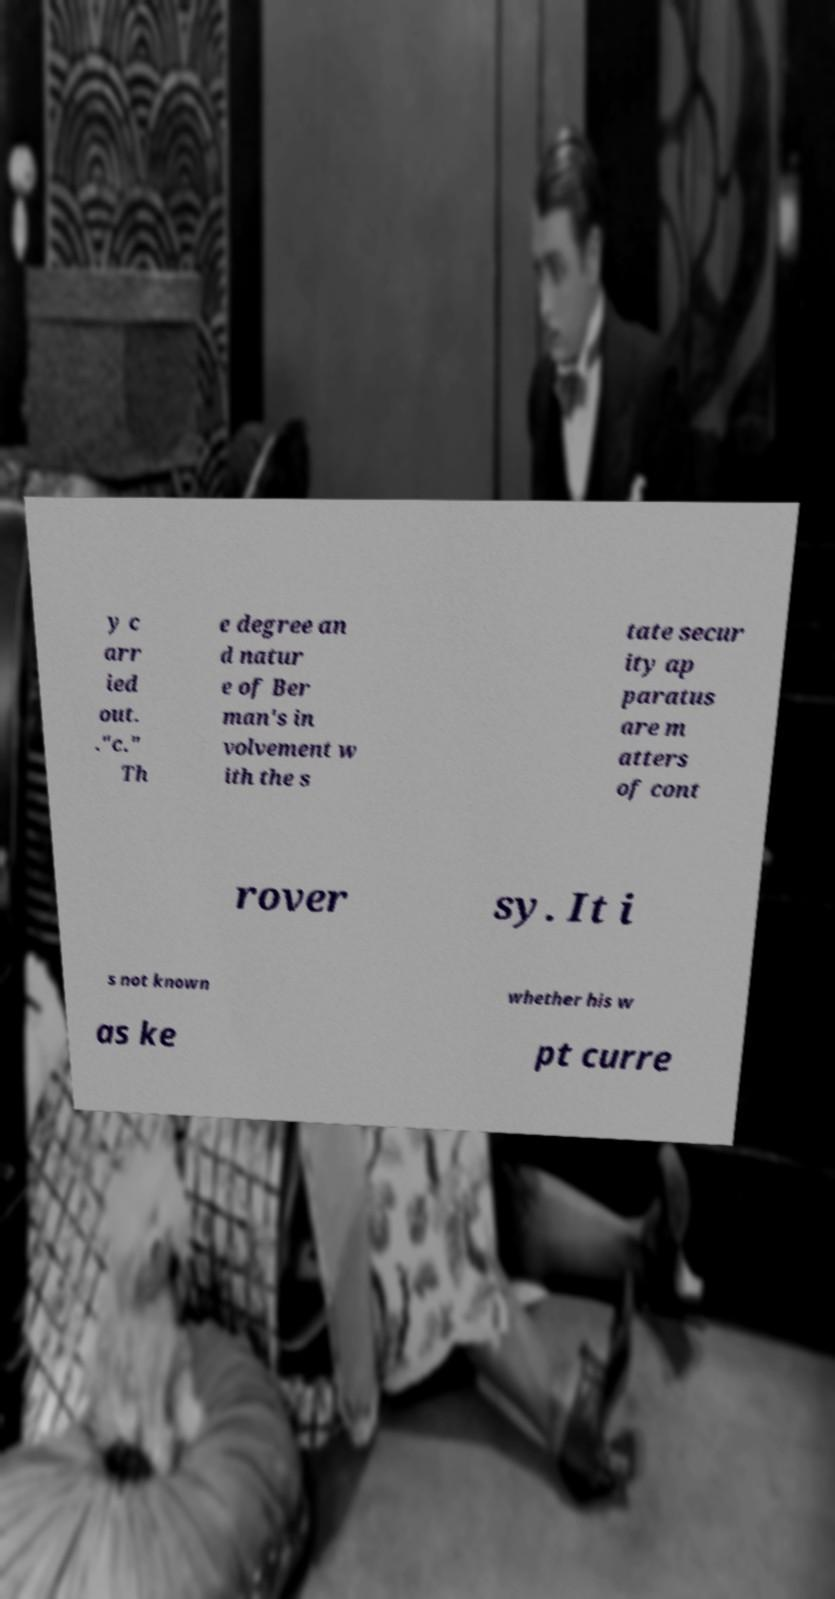What messages or text are displayed in this image? I need them in a readable, typed format. y c arr ied out. ."c." Th e degree an d natur e of Ber man's in volvement w ith the s tate secur ity ap paratus are m atters of cont rover sy. It i s not known whether his w as ke pt curre 